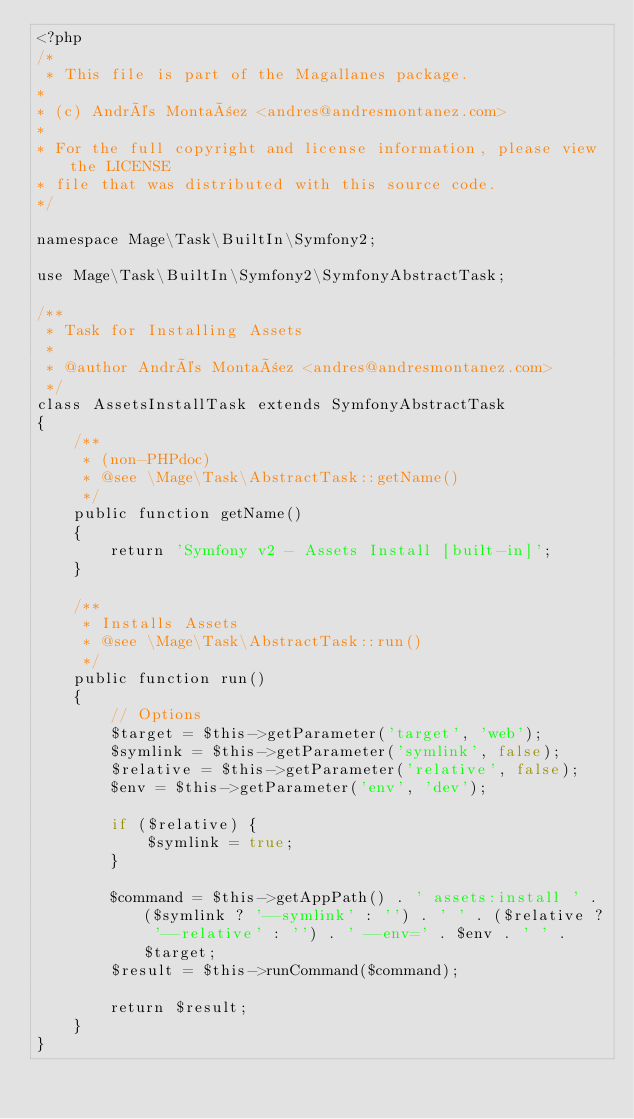<code> <loc_0><loc_0><loc_500><loc_500><_PHP_><?php
/*
 * This file is part of the Magallanes package.
*
* (c) Andrés Montañez <andres@andresmontanez.com>
*
* For the full copyright and license information, please view the LICENSE
* file that was distributed with this source code.
*/

namespace Mage\Task\BuiltIn\Symfony2;

use Mage\Task\BuiltIn\Symfony2\SymfonyAbstractTask;

/**
 * Task for Installing Assets
 *
 * @author Andrés Montañez <andres@andresmontanez.com>
 */
class AssetsInstallTask extends SymfonyAbstractTask
{
    /**
     * (non-PHPdoc)
     * @see \Mage\Task\AbstractTask::getName()
     */
    public function getName()
    {
        return 'Symfony v2 - Assets Install [built-in]';
    }

    /**
     * Installs Assets
     * @see \Mage\Task\AbstractTask::run()
     */
    public function run()
    {
        // Options
        $target = $this->getParameter('target', 'web');
        $symlink = $this->getParameter('symlink', false);
        $relative = $this->getParameter('relative', false);
        $env = $this->getParameter('env', 'dev');

        if ($relative) {
            $symlink = true;
        }

        $command = $this->getAppPath() . ' assets:install ' . ($symlink ? '--symlink' : '') . ' ' . ($relative ? '--relative' : '') . ' --env=' . $env . ' ' . $target;
        $result = $this->runCommand($command);

        return $result;
    }
}
</code> 